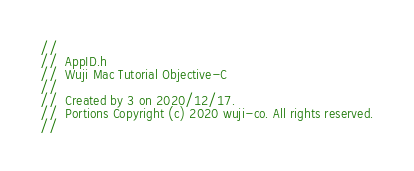Convert code to text. <code><loc_0><loc_0><loc_500><loc_500><_C_>//
//  AppID.h
//  Wuji Mac Tutorial Objective-C
//
//  Created by 3 on 2020/12/17.
//  Portions Copyright (c) 2020 wuji-co. All rights reserved.
//
</code> 